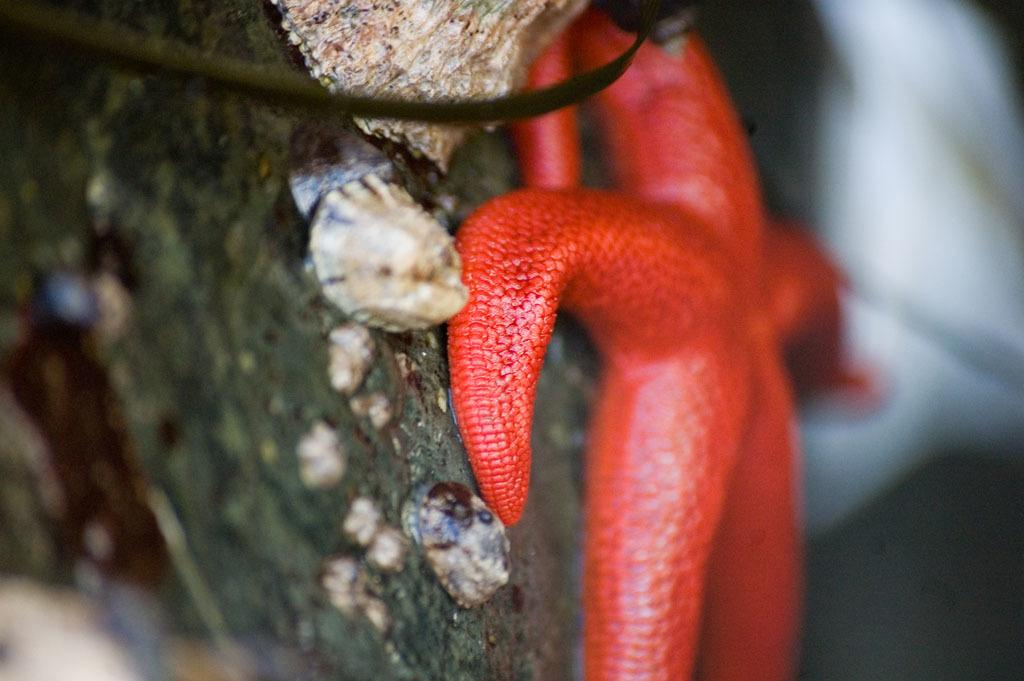What is the color of the starfish in the image? The starfish in the image is red. Where is the starfish located in the image? The starfish is on a surface. Can you describe the background of the image? The background of the image is blurred. What type of copper material is used to create the limit of the starfish's movement in the image? There is no copper material or limit to the starfish's movement in the image, as it is a static image of a starfish on a surface. 